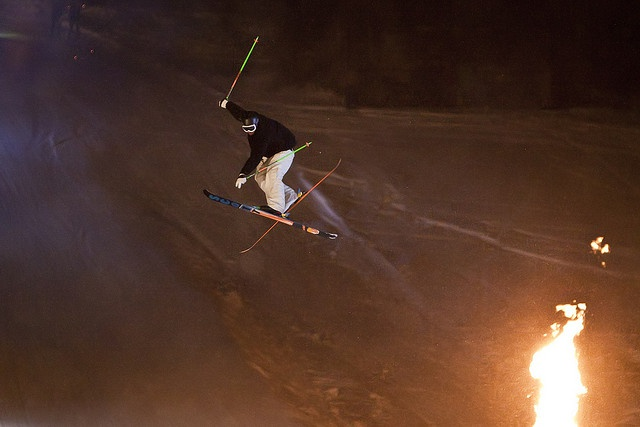Describe the objects in this image and their specific colors. I can see people in black, lightgray, tan, and maroon tones and skis in black, maroon, gray, and salmon tones in this image. 